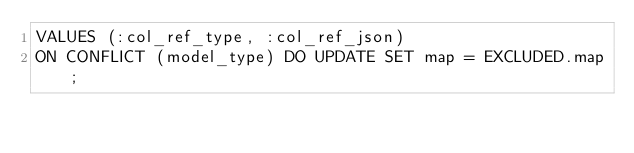Convert code to text. <code><loc_0><loc_0><loc_500><loc_500><_SQL_>VALUES (:col_ref_type, :col_ref_json)
ON CONFLICT (model_type) DO UPDATE SET map = EXCLUDED.map;</code> 